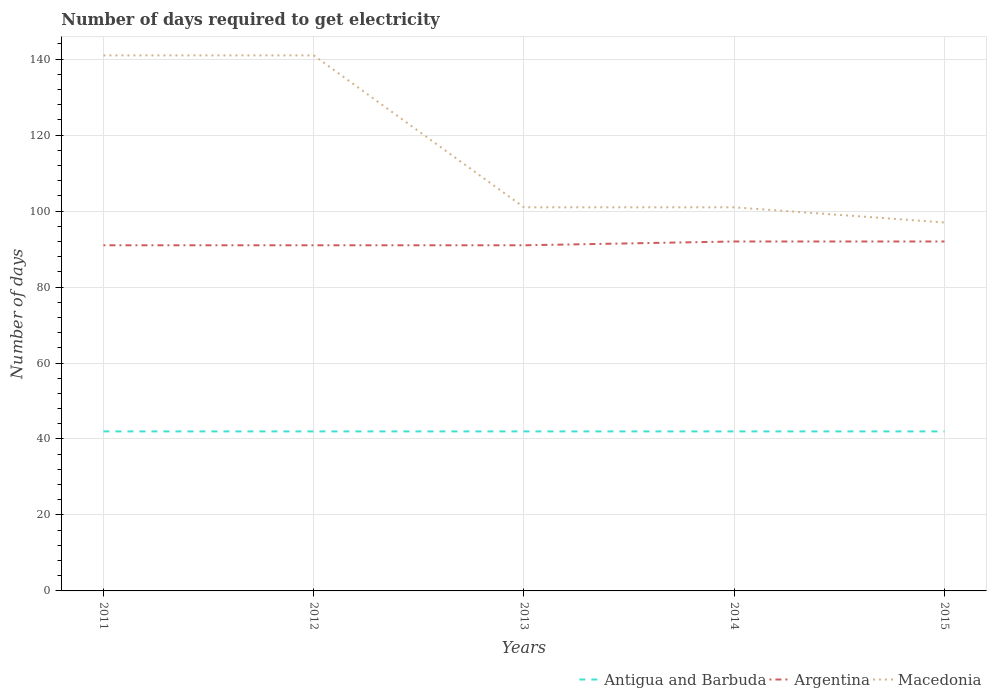How many different coloured lines are there?
Your answer should be very brief. 3. Across all years, what is the maximum number of days required to get electricity in in Argentina?
Your answer should be compact. 91. What is the total number of days required to get electricity in in Macedonia in the graph?
Your answer should be very brief. 4. What is the difference between the highest and the second highest number of days required to get electricity in in Argentina?
Make the answer very short. 1. Is the number of days required to get electricity in in Argentina strictly greater than the number of days required to get electricity in in Macedonia over the years?
Give a very brief answer. Yes. How many years are there in the graph?
Offer a terse response. 5. What is the difference between two consecutive major ticks on the Y-axis?
Keep it short and to the point. 20. Are the values on the major ticks of Y-axis written in scientific E-notation?
Offer a very short reply. No. Where does the legend appear in the graph?
Make the answer very short. Bottom right. How many legend labels are there?
Your answer should be compact. 3. What is the title of the graph?
Provide a succinct answer. Number of days required to get electricity. Does "Cuba" appear as one of the legend labels in the graph?
Offer a terse response. No. What is the label or title of the X-axis?
Provide a succinct answer. Years. What is the label or title of the Y-axis?
Your response must be concise. Number of days. What is the Number of days of Antigua and Barbuda in 2011?
Give a very brief answer. 42. What is the Number of days in Argentina in 2011?
Provide a succinct answer. 91. What is the Number of days of Macedonia in 2011?
Make the answer very short. 141. What is the Number of days in Argentina in 2012?
Make the answer very short. 91. What is the Number of days in Macedonia in 2012?
Give a very brief answer. 141. What is the Number of days in Argentina in 2013?
Your answer should be compact. 91. What is the Number of days in Macedonia in 2013?
Your response must be concise. 101. What is the Number of days of Argentina in 2014?
Give a very brief answer. 92. What is the Number of days of Macedonia in 2014?
Provide a short and direct response. 101. What is the Number of days in Argentina in 2015?
Make the answer very short. 92. What is the Number of days in Macedonia in 2015?
Provide a succinct answer. 97. Across all years, what is the maximum Number of days in Antigua and Barbuda?
Your response must be concise. 42. Across all years, what is the maximum Number of days in Argentina?
Offer a terse response. 92. Across all years, what is the maximum Number of days of Macedonia?
Offer a terse response. 141. Across all years, what is the minimum Number of days in Argentina?
Ensure brevity in your answer.  91. Across all years, what is the minimum Number of days of Macedonia?
Give a very brief answer. 97. What is the total Number of days of Antigua and Barbuda in the graph?
Make the answer very short. 210. What is the total Number of days of Argentina in the graph?
Offer a terse response. 457. What is the total Number of days of Macedonia in the graph?
Provide a short and direct response. 581. What is the difference between the Number of days of Macedonia in 2011 and that in 2012?
Your answer should be very brief. 0. What is the difference between the Number of days in Antigua and Barbuda in 2011 and that in 2013?
Your answer should be compact. 0. What is the difference between the Number of days of Macedonia in 2011 and that in 2013?
Give a very brief answer. 40. What is the difference between the Number of days in Antigua and Barbuda in 2012 and that in 2013?
Offer a terse response. 0. What is the difference between the Number of days of Argentina in 2012 and that in 2013?
Make the answer very short. 0. What is the difference between the Number of days of Macedonia in 2012 and that in 2013?
Offer a terse response. 40. What is the difference between the Number of days in Antigua and Barbuda in 2012 and that in 2014?
Keep it short and to the point. 0. What is the difference between the Number of days in Argentina in 2012 and that in 2014?
Ensure brevity in your answer.  -1. What is the difference between the Number of days in Macedonia in 2012 and that in 2014?
Keep it short and to the point. 40. What is the difference between the Number of days of Antigua and Barbuda in 2012 and that in 2015?
Provide a succinct answer. 0. What is the difference between the Number of days of Macedonia in 2012 and that in 2015?
Your answer should be compact. 44. What is the difference between the Number of days in Antigua and Barbuda in 2013 and that in 2014?
Your answer should be very brief. 0. What is the difference between the Number of days of Argentina in 2013 and that in 2014?
Offer a terse response. -1. What is the difference between the Number of days of Antigua and Barbuda in 2013 and that in 2015?
Provide a succinct answer. 0. What is the difference between the Number of days of Antigua and Barbuda in 2014 and that in 2015?
Offer a very short reply. 0. What is the difference between the Number of days of Argentina in 2014 and that in 2015?
Offer a terse response. 0. What is the difference between the Number of days in Antigua and Barbuda in 2011 and the Number of days in Argentina in 2012?
Give a very brief answer. -49. What is the difference between the Number of days in Antigua and Barbuda in 2011 and the Number of days in Macedonia in 2012?
Your answer should be compact. -99. What is the difference between the Number of days in Argentina in 2011 and the Number of days in Macedonia in 2012?
Provide a short and direct response. -50. What is the difference between the Number of days of Antigua and Barbuda in 2011 and the Number of days of Argentina in 2013?
Give a very brief answer. -49. What is the difference between the Number of days in Antigua and Barbuda in 2011 and the Number of days in Macedonia in 2013?
Offer a very short reply. -59. What is the difference between the Number of days in Argentina in 2011 and the Number of days in Macedonia in 2013?
Make the answer very short. -10. What is the difference between the Number of days of Antigua and Barbuda in 2011 and the Number of days of Macedonia in 2014?
Offer a terse response. -59. What is the difference between the Number of days of Argentina in 2011 and the Number of days of Macedonia in 2014?
Give a very brief answer. -10. What is the difference between the Number of days of Antigua and Barbuda in 2011 and the Number of days of Macedonia in 2015?
Your answer should be compact. -55. What is the difference between the Number of days of Argentina in 2011 and the Number of days of Macedonia in 2015?
Ensure brevity in your answer.  -6. What is the difference between the Number of days of Antigua and Barbuda in 2012 and the Number of days of Argentina in 2013?
Your answer should be very brief. -49. What is the difference between the Number of days of Antigua and Barbuda in 2012 and the Number of days of Macedonia in 2013?
Offer a terse response. -59. What is the difference between the Number of days in Antigua and Barbuda in 2012 and the Number of days in Macedonia in 2014?
Make the answer very short. -59. What is the difference between the Number of days in Argentina in 2012 and the Number of days in Macedonia in 2014?
Make the answer very short. -10. What is the difference between the Number of days in Antigua and Barbuda in 2012 and the Number of days in Macedonia in 2015?
Ensure brevity in your answer.  -55. What is the difference between the Number of days of Argentina in 2012 and the Number of days of Macedonia in 2015?
Provide a succinct answer. -6. What is the difference between the Number of days of Antigua and Barbuda in 2013 and the Number of days of Argentina in 2014?
Make the answer very short. -50. What is the difference between the Number of days in Antigua and Barbuda in 2013 and the Number of days in Macedonia in 2014?
Make the answer very short. -59. What is the difference between the Number of days in Argentina in 2013 and the Number of days in Macedonia in 2014?
Your answer should be very brief. -10. What is the difference between the Number of days of Antigua and Barbuda in 2013 and the Number of days of Macedonia in 2015?
Offer a very short reply. -55. What is the difference between the Number of days in Argentina in 2013 and the Number of days in Macedonia in 2015?
Provide a succinct answer. -6. What is the difference between the Number of days in Antigua and Barbuda in 2014 and the Number of days in Argentina in 2015?
Your response must be concise. -50. What is the difference between the Number of days of Antigua and Barbuda in 2014 and the Number of days of Macedonia in 2015?
Provide a short and direct response. -55. What is the average Number of days in Antigua and Barbuda per year?
Offer a very short reply. 42. What is the average Number of days in Argentina per year?
Ensure brevity in your answer.  91.4. What is the average Number of days of Macedonia per year?
Your response must be concise. 116.2. In the year 2011, what is the difference between the Number of days of Antigua and Barbuda and Number of days of Argentina?
Provide a short and direct response. -49. In the year 2011, what is the difference between the Number of days in Antigua and Barbuda and Number of days in Macedonia?
Your answer should be compact. -99. In the year 2011, what is the difference between the Number of days in Argentina and Number of days in Macedonia?
Your answer should be very brief. -50. In the year 2012, what is the difference between the Number of days of Antigua and Barbuda and Number of days of Argentina?
Provide a short and direct response. -49. In the year 2012, what is the difference between the Number of days of Antigua and Barbuda and Number of days of Macedonia?
Your answer should be compact. -99. In the year 2013, what is the difference between the Number of days of Antigua and Barbuda and Number of days of Argentina?
Your answer should be compact. -49. In the year 2013, what is the difference between the Number of days in Antigua and Barbuda and Number of days in Macedonia?
Offer a very short reply. -59. In the year 2014, what is the difference between the Number of days of Antigua and Barbuda and Number of days of Argentina?
Provide a short and direct response. -50. In the year 2014, what is the difference between the Number of days in Antigua and Barbuda and Number of days in Macedonia?
Keep it short and to the point. -59. In the year 2015, what is the difference between the Number of days of Antigua and Barbuda and Number of days of Macedonia?
Offer a very short reply. -55. In the year 2015, what is the difference between the Number of days of Argentina and Number of days of Macedonia?
Provide a short and direct response. -5. What is the ratio of the Number of days in Argentina in 2011 to that in 2012?
Your answer should be very brief. 1. What is the ratio of the Number of days of Macedonia in 2011 to that in 2012?
Make the answer very short. 1. What is the ratio of the Number of days of Antigua and Barbuda in 2011 to that in 2013?
Your response must be concise. 1. What is the ratio of the Number of days of Macedonia in 2011 to that in 2013?
Provide a short and direct response. 1.4. What is the ratio of the Number of days in Antigua and Barbuda in 2011 to that in 2014?
Ensure brevity in your answer.  1. What is the ratio of the Number of days of Argentina in 2011 to that in 2014?
Your answer should be very brief. 0.99. What is the ratio of the Number of days in Macedonia in 2011 to that in 2014?
Your answer should be compact. 1.4. What is the ratio of the Number of days of Antigua and Barbuda in 2011 to that in 2015?
Provide a short and direct response. 1. What is the ratio of the Number of days in Macedonia in 2011 to that in 2015?
Your response must be concise. 1.45. What is the ratio of the Number of days in Macedonia in 2012 to that in 2013?
Provide a succinct answer. 1.4. What is the ratio of the Number of days in Antigua and Barbuda in 2012 to that in 2014?
Provide a short and direct response. 1. What is the ratio of the Number of days of Macedonia in 2012 to that in 2014?
Ensure brevity in your answer.  1.4. What is the ratio of the Number of days in Antigua and Barbuda in 2012 to that in 2015?
Your answer should be very brief. 1. What is the ratio of the Number of days in Macedonia in 2012 to that in 2015?
Your answer should be compact. 1.45. What is the ratio of the Number of days of Antigua and Barbuda in 2013 to that in 2014?
Make the answer very short. 1. What is the ratio of the Number of days in Macedonia in 2013 to that in 2014?
Offer a very short reply. 1. What is the ratio of the Number of days in Antigua and Barbuda in 2013 to that in 2015?
Offer a terse response. 1. What is the ratio of the Number of days of Macedonia in 2013 to that in 2015?
Provide a short and direct response. 1.04. What is the ratio of the Number of days of Antigua and Barbuda in 2014 to that in 2015?
Give a very brief answer. 1. What is the ratio of the Number of days in Macedonia in 2014 to that in 2015?
Ensure brevity in your answer.  1.04. What is the difference between the highest and the second highest Number of days in Argentina?
Provide a succinct answer. 0. What is the difference between the highest and the second highest Number of days in Macedonia?
Ensure brevity in your answer.  0. What is the difference between the highest and the lowest Number of days in Antigua and Barbuda?
Offer a very short reply. 0. What is the difference between the highest and the lowest Number of days in Argentina?
Your answer should be compact. 1. 